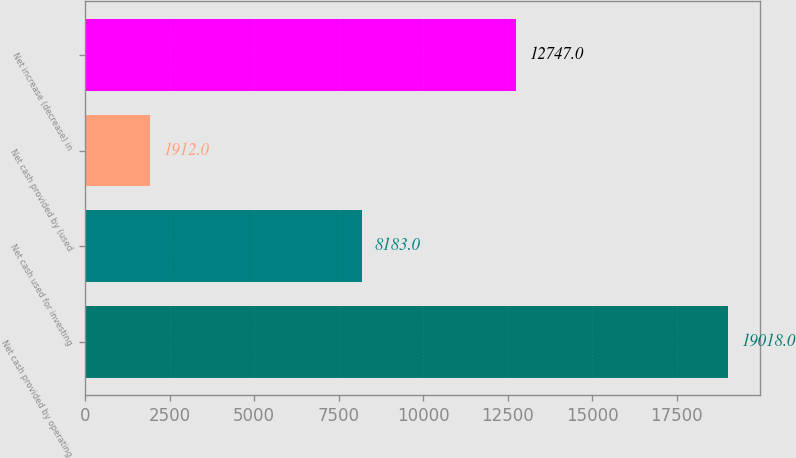Convert chart. <chart><loc_0><loc_0><loc_500><loc_500><bar_chart><fcel>Net cash provided by operating<fcel>Net cash used for investing<fcel>Net cash provided by (used<fcel>Net increase (decrease) in<nl><fcel>19018<fcel>8183<fcel>1912<fcel>12747<nl></chart> 